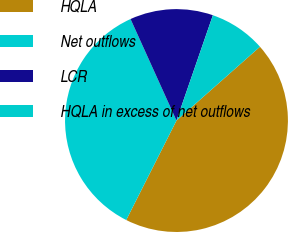Convert chart. <chart><loc_0><loc_0><loc_500><loc_500><pie_chart><fcel>HQLA<fcel>Net outflows<fcel>LCR<fcel>HQLA in excess of net outflows<nl><fcel>43.97%<fcel>35.79%<fcel>12.06%<fcel>8.18%<nl></chart> 